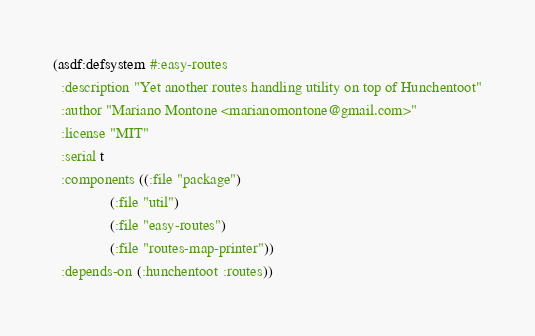<code> <loc_0><loc_0><loc_500><loc_500><_Lisp_>(asdf:defsystem #:easy-routes
  :description "Yet another routes handling utility on top of Hunchentoot"
  :author "Mariano Montone <marianomontone@gmail.com>"
  :license "MIT"
  :serial t
  :components ((:file "package")
               (:file "util")
               (:file "easy-routes")
               (:file "routes-map-printer"))
  :depends-on (:hunchentoot :routes))
</code> 